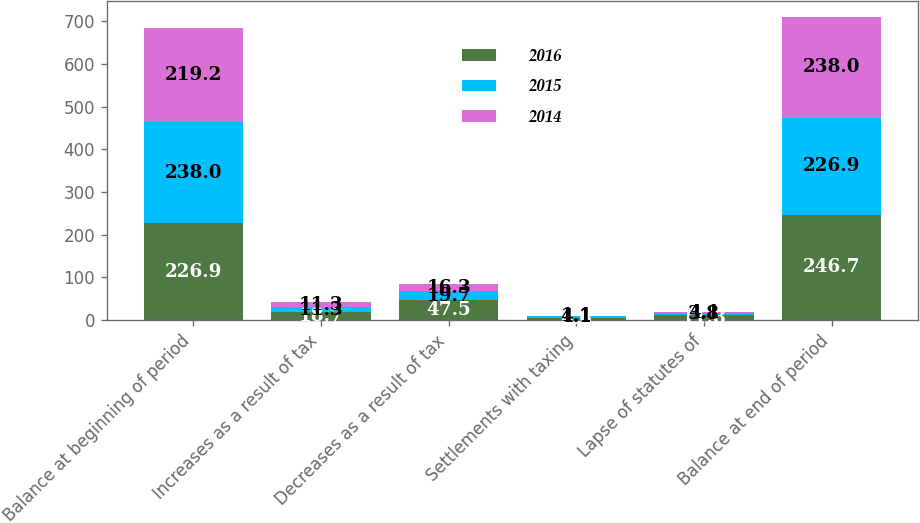<chart> <loc_0><loc_0><loc_500><loc_500><stacked_bar_chart><ecel><fcel>Balance at beginning of period<fcel>Increases as a result of tax<fcel>Decreases as a result of tax<fcel>Settlements with taxing<fcel>Lapse of statutes of<fcel>Balance at end of period<nl><fcel>2016<fcel>226.9<fcel>18.7<fcel>47.5<fcel>4.6<fcel>11.8<fcel>246.7<nl><fcel>2015<fcel>238<fcel>11.3<fcel>19.7<fcel>4.1<fcel>3.8<fcel>226.9<nl><fcel>2014<fcel>219.2<fcel>11.3<fcel>16.3<fcel>1.1<fcel>4.1<fcel>238<nl></chart> 